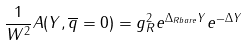Convert formula to latex. <formula><loc_0><loc_0><loc_500><loc_500>\frac { 1 } { W ^ { 2 } } A ( Y , \overline { q } = 0 ) = g _ { R } ^ { 2 } e ^ { \Delta _ { R b a r e } Y } e ^ { - \Delta Y } \\</formula> 